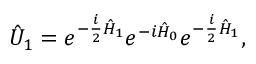<formula> <loc_0><loc_0><loc_500><loc_500>\hat { U } _ { 1 } = e ^ { - \frac { i } { 2 } \hat { H } _ { 1 } } e ^ { - i \hat { H } _ { 0 } } e ^ { - \frac { i } { 2 } \hat { H } _ { 1 } } ,</formula> 